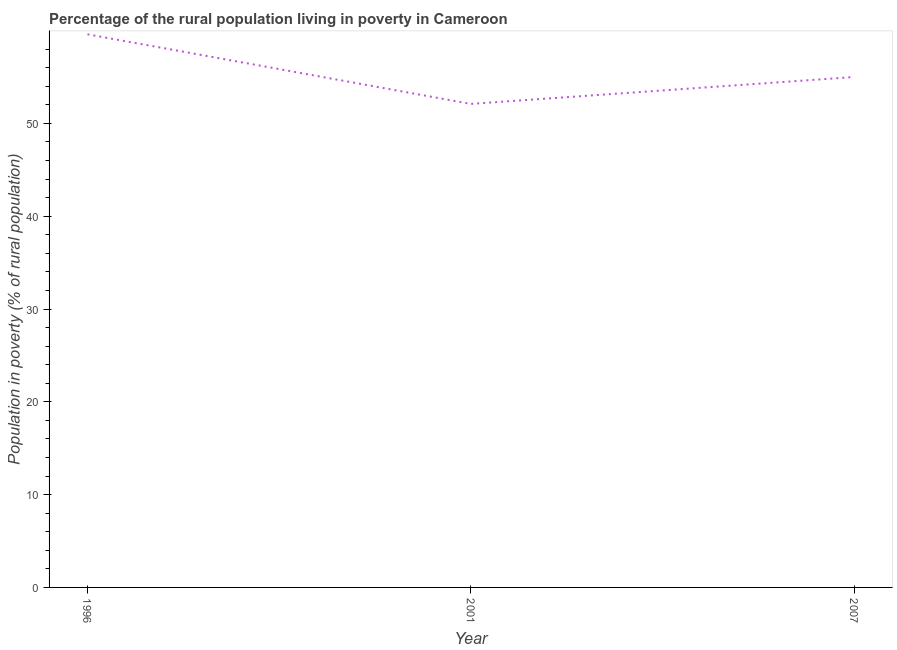Across all years, what is the maximum percentage of rural population living below poverty line?
Your response must be concise. 59.6. Across all years, what is the minimum percentage of rural population living below poverty line?
Provide a short and direct response. 52.1. In which year was the percentage of rural population living below poverty line maximum?
Offer a terse response. 1996. In which year was the percentage of rural population living below poverty line minimum?
Offer a very short reply. 2001. What is the sum of the percentage of rural population living below poverty line?
Provide a succinct answer. 166.7. What is the difference between the percentage of rural population living below poverty line in 2001 and 2007?
Your response must be concise. -2.9. What is the average percentage of rural population living below poverty line per year?
Your answer should be very brief. 55.57. What is the ratio of the percentage of rural population living below poverty line in 1996 to that in 2007?
Make the answer very short. 1.08. What is the difference between the highest and the second highest percentage of rural population living below poverty line?
Provide a succinct answer. 4.6. What is the difference between the highest and the lowest percentage of rural population living below poverty line?
Keep it short and to the point. 7.5. Does the percentage of rural population living below poverty line monotonically increase over the years?
Your answer should be compact. No. How many years are there in the graph?
Your response must be concise. 3. Does the graph contain any zero values?
Provide a succinct answer. No. Does the graph contain grids?
Make the answer very short. No. What is the title of the graph?
Give a very brief answer. Percentage of the rural population living in poverty in Cameroon. What is the label or title of the X-axis?
Your answer should be compact. Year. What is the label or title of the Y-axis?
Offer a very short reply. Population in poverty (% of rural population). What is the Population in poverty (% of rural population) in 1996?
Your answer should be compact. 59.6. What is the Population in poverty (% of rural population) of 2001?
Your answer should be compact. 52.1. What is the difference between the Population in poverty (% of rural population) in 1996 and 2001?
Give a very brief answer. 7.5. What is the difference between the Population in poverty (% of rural population) in 1996 and 2007?
Provide a short and direct response. 4.6. What is the ratio of the Population in poverty (% of rural population) in 1996 to that in 2001?
Make the answer very short. 1.14. What is the ratio of the Population in poverty (% of rural population) in 1996 to that in 2007?
Offer a very short reply. 1.08. What is the ratio of the Population in poverty (% of rural population) in 2001 to that in 2007?
Ensure brevity in your answer.  0.95. 